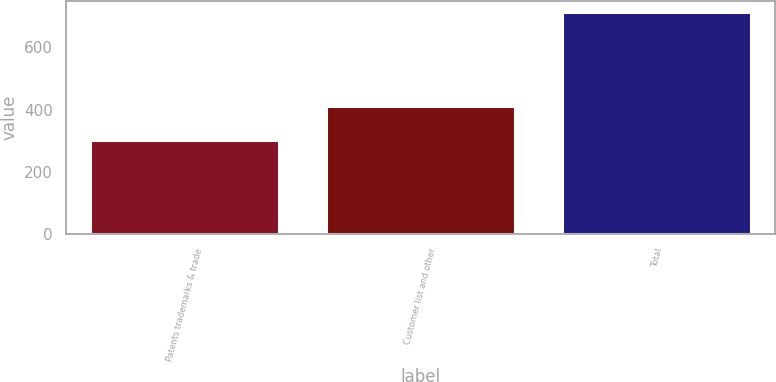<chart> <loc_0><loc_0><loc_500><loc_500><bar_chart><fcel>Patents trademarks & trade<fcel>Customer list and other<fcel>Total<nl><fcel>302<fcel>411<fcel>713<nl></chart> 